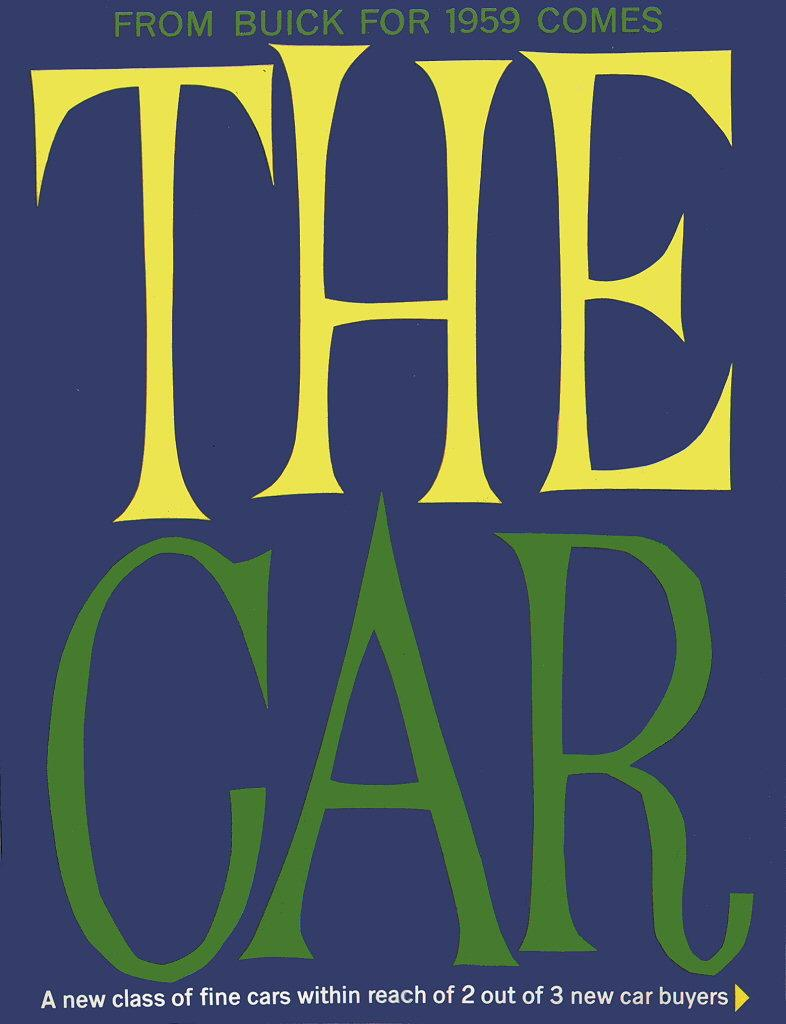Provide a one-sentence caption for the provided image. blue background with large the car on it in yellow and green letters. 